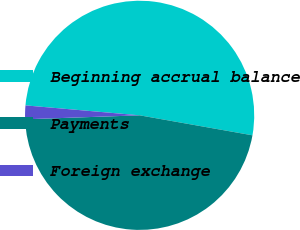Convert chart. <chart><loc_0><loc_0><loc_500><loc_500><pie_chart><fcel>Beginning accrual balance<fcel>Payments<fcel>Foreign exchange<nl><fcel>51.41%<fcel>46.66%<fcel>1.93%<nl></chart> 